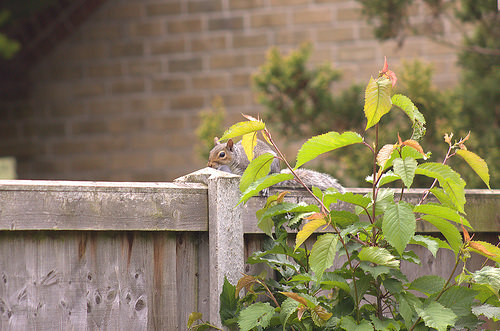<image>
Can you confirm if the fence is in front of the squirrel? No. The fence is not in front of the squirrel. The spatial positioning shows a different relationship between these objects. 